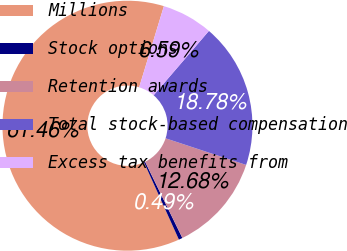Convert chart. <chart><loc_0><loc_0><loc_500><loc_500><pie_chart><fcel>Millions<fcel>Stock options<fcel>Retention awards<fcel>Total stock-based compensation<fcel>Excess tax benefits from<nl><fcel>61.46%<fcel>0.49%<fcel>12.68%<fcel>18.78%<fcel>6.59%<nl></chart> 